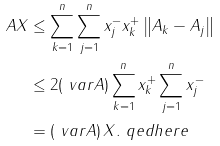Convert formula to latex. <formula><loc_0><loc_0><loc_500><loc_500>\| A X \| & \leq \sum _ { k = 1 } ^ { n } \sum _ { j = 1 } ^ { n } x _ { j } ^ { - } x _ { k } ^ { + } \left \| A _ { k } - A _ { j } \right \| \\ & \leq 2 ( \ v a r A ) \sum _ { k = 1 } ^ { n } x _ { k } ^ { + } \sum _ { j = 1 } ^ { n } x _ { j } ^ { - } \\ & = ( \ v a r A ) \, \| X \| . \ q e d h e r e</formula> 